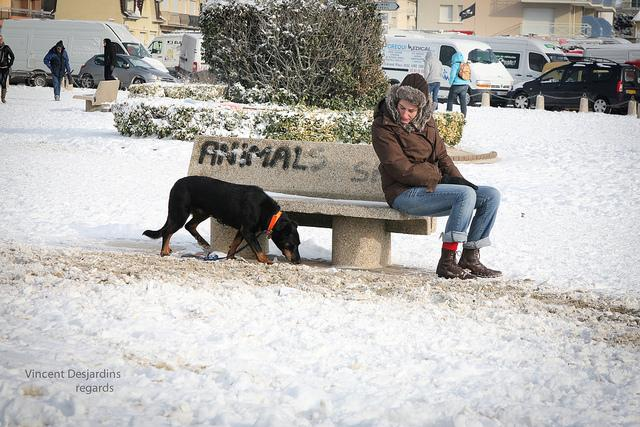What physical danger could she face if she was stuck in the cold with no winter apparel?

Choices:
A) frostbite
B) sunburn
C) nothing
D) chicken pox frostbite 